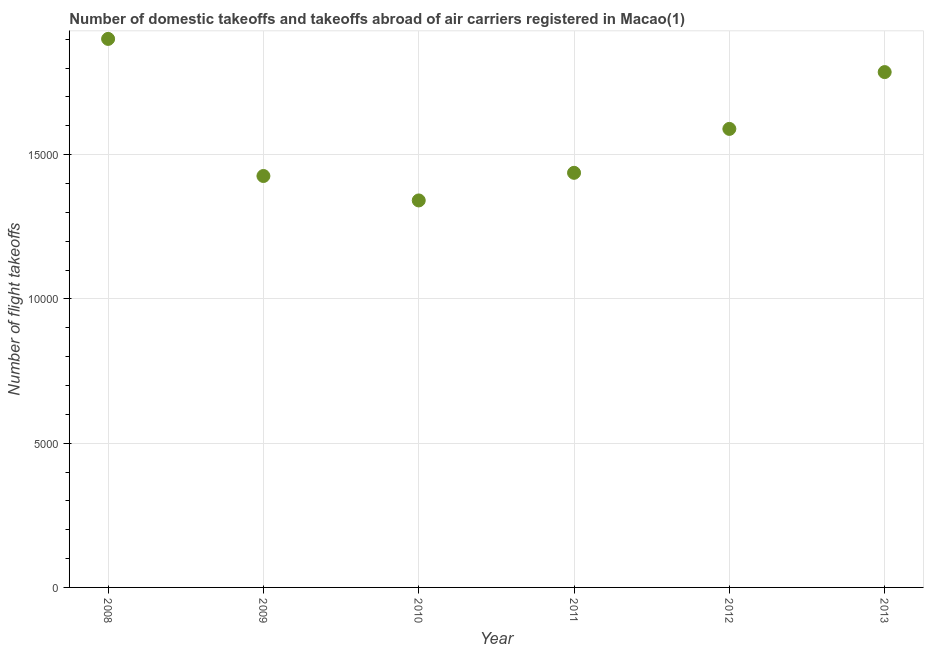What is the number of flight takeoffs in 2011?
Provide a succinct answer. 1.44e+04. Across all years, what is the maximum number of flight takeoffs?
Make the answer very short. 1.90e+04. Across all years, what is the minimum number of flight takeoffs?
Provide a short and direct response. 1.34e+04. In which year was the number of flight takeoffs maximum?
Provide a succinct answer. 2008. What is the sum of the number of flight takeoffs?
Offer a very short reply. 9.48e+04. What is the difference between the number of flight takeoffs in 2010 and 2011?
Your response must be concise. -957. What is the average number of flight takeoffs per year?
Give a very brief answer. 1.58e+04. What is the median number of flight takeoffs?
Offer a terse response. 1.51e+04. Do a majority of the years between 2009 and 2011 (inclusive) have number of flight takeoffs greater than 1000 ?
Provide a succinct answer. Yes. What is the ratio of the number of flight takeoffs in 2008 to that in 2010?
Keep it short and to the point. 1.42. What is the difference between the highest and the second highest number of flight takeoffs?
Your answer should be very brief. 1150. What is the difference between the highest and the lowest number of flight takeoffs?
Offer a terse response. 5598. Does the number of flight takeoffs monotonically increase over the years?
Make the answer very short. No. Does the graph contain any zero values?
Ensure brevity in your answer.  No. Does the graph contain grids?
Offer a terse response. Yes. What is the title of the graph?
Give a very brief answer. Number of domestic takeoffs and takeoffs abroad of air carriers registered in Macao(1). What is the label or title of the Y-axis?
Your answer should be compact. Number of flight takeoffs. What is the Number of flight takeoffs in 2008?
Make the answer very short. 1.90e+04. What is the Number of flight takeoffs in 2009?
Ensure brevity in your answer.  1.43e+04. What is the Number of flight takeoffs in 2010?
Offer a terse response. 1.34e+04. What is the Number of flight takeoffs in 2011?
Provide a succinct answer. 1.44e+04. What is the Number of flight takeoffs in 2012?
Provide a short and direct response. 1.59e+04. What is the Number of flight takeoffs in 2013?
Your answer should be very brief. 1.79e+04. What is the difference between the Number of flight takeoffs in 2008 and 2009?
Make the answer very short. 4751. What is the difference between the Number of flight takeoffs in 2008 and 2010?
Provide a succinct answer. 5598. What is the difference between the Number of flight takeoffs in 2008 and 2011?
Give a very brief answer. 4641. What is the difference between the Number of flight takeoffs in 2008 and 2012?
Ensure brevity in your answer.  3119. What is the difference between the Number of flight takeoffs in 2008 and 2013?
Provide a succinct answer. 1150. What is the difference between the Number of flight takeoffs in 2009 and 2010?
Provide a succinct answer. 847. What is the difference between the Number of flight takeoffs in 2009 and 2011?
Keep it short and to the point. -110. What is the difference between the Number of flight takeoffs in 2009 and 2012?
Your answer should be compact. -1632. What is the difference between the Number of flight takeoffs in 2009 and 2013?
Your response must be concise. -3601. What is the difference between the Number of flight takeoffs in 2010 and 2011?
Your response must be concise. -957. What is the difference between the Number of flight takeoffs in 2010 and 2012?
Your answer should be compact. -2479. What is the difference between the Number of flight takeoffs in 2010 and 2013?
Ensure brevity in your answer.  -4448. What is the difference between the Number of flight takeoffs in 2011 and 2012?
Your response must be concise. -1522. What is the difference between the Number of flight takeoffs in 2011 and 2013?
Your answer should be compact. -3491. What is the difference between the Number of flight takeoffs in 2012 and 2013?
Give a very brief answer. -1969. What is the ratio of the Number of flight takeoffs in 2008 to that in 2009?
Offer a terse response. 1.33. What is the ratio of the Number of flight takeoffs in 2008 to that in 2010?
Offer a very short reply. 1.42. What is the ratio of the Number of flight takeoffs in 2008 to that in 2011?
Provide a short and direct response. 1.32. What is the ratio of the Number of flight takeoffs in 2008 to that in 2012?
Keep it short and to the point. 1.2. What is the ratio of the Number of flight takeoffs in 2008 to that in 2013?
Keep it short and to the point. 1.06. What is the ratio of the Number of flight takeoffs in 2009 to that in 2010?
Offer a terse response. 1.06. What is the ratio of the Number of flight takeoffs in 2009 to that in 2011?
Give a very brief answer. 0.99. What is the ratio of the Number of flight takeoffs in 2009 to that in 2012?
Offer a very short reply. 0.9. What is the ratio of the Number of flight takeoffs in 2009 to that in 2013?
Provide a short and direct response. 0.8. What is the ratio of the Number of flight takeoffs in 2010 to that in 2011?
Offer a terse response. 0.93. What is the ratio of the Number of flight takeoffs in 2010 to that in 2012?
Provide a succinct answer. 0.84. What is the ratio of the Number of flight takeoffs in 2010 to that in 2013?
Make the answer very short. 0.75. What is the ratio of the Number of flight takeoffs in 2011 to that in 2012?
Make the answer very short. 0.9. What is the ratio of the Number of flight takeoffs in 2011 to that in 2013?
Ensure brevity in your answer.  0.81. What is the ratio of the Number of flight takeoffs in 2012 to that in 2013?
Provide a succinct answer. 0.89. 